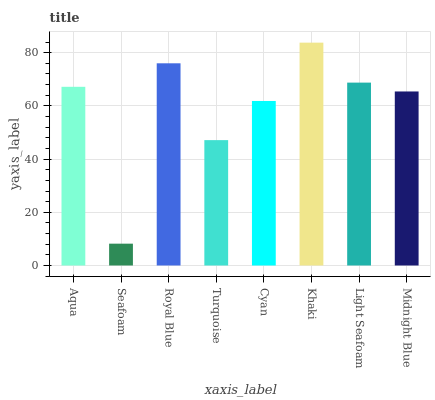Is Seafoam the minimum?
Answer yes or no. Yes. Is Khaki the maximum?
Answer yes or no. Yes. Is Royal Blue the minimum?
Answer yes or no. No. Is Royal Blue the maximum?
Answer yes or no. No. Is Royal Blue greater than Seafoam?
Answer yes or no. Yes. Is Seafoam less than Royal Blue?
Answer yes or no. Yes. Is Seafoam greater than Royal Blue?
Answer yes or no. No. Is Royal Blue less than Seafoam?
Answer yes or no. No. Is Aqua the high median?
Answer yes or no. Yes. Is Midnight Blue the low median?
Answer yes or no. Yes. Is Royal Blue the high median?
Answer yes or no. No. Is Royal Blue the low median?
Answer yes or no. No. 